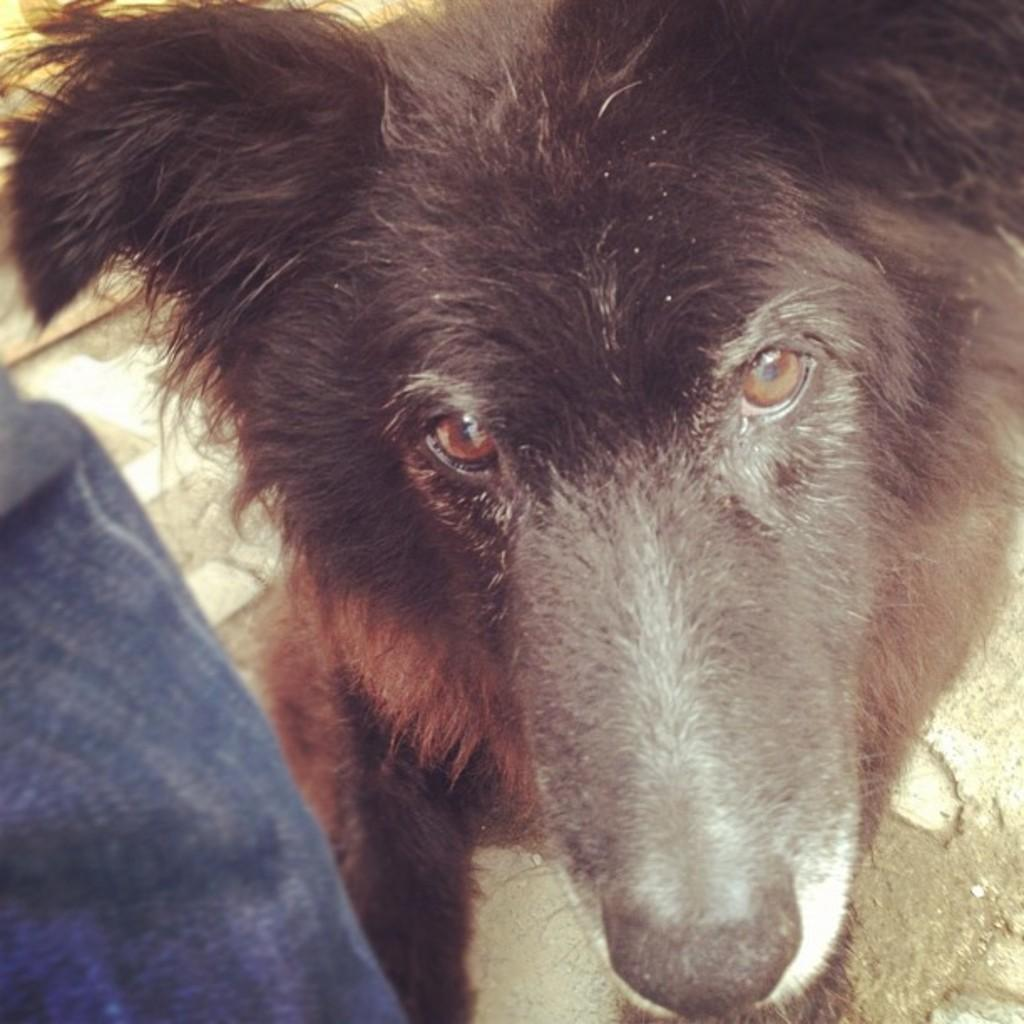What type of animal is present in the image? There is an animal in the image, but the specific type cannot be determined from the provided facts. Can you describe the object located in the bottom left corner of the image? Unfortunately, the facts do not provide enough information to describe the object in the bottom left corner of the image. How does the ocean affect the animal in the image? There is no ocean present in the image, so it cannot affect the animal. What achievements has the achiever in the image accomplished? There is no achiever present in the image, so their achievements cannot be discussed. 